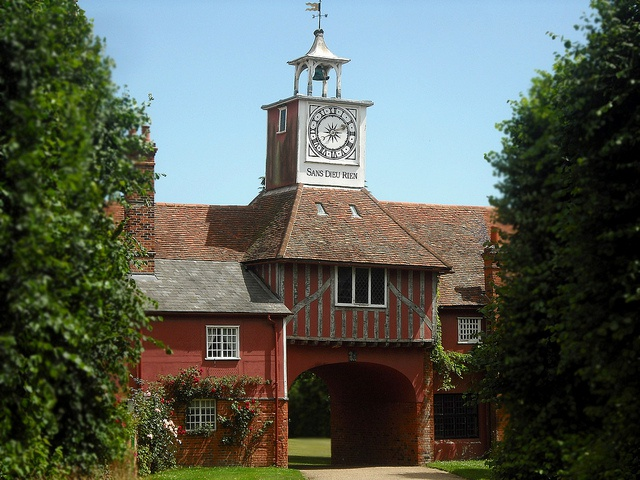Describe the objects in this image and their specific colors. I can see a clock in darkgreen, lightgray, darkgray, gray, and black tones in this image. 